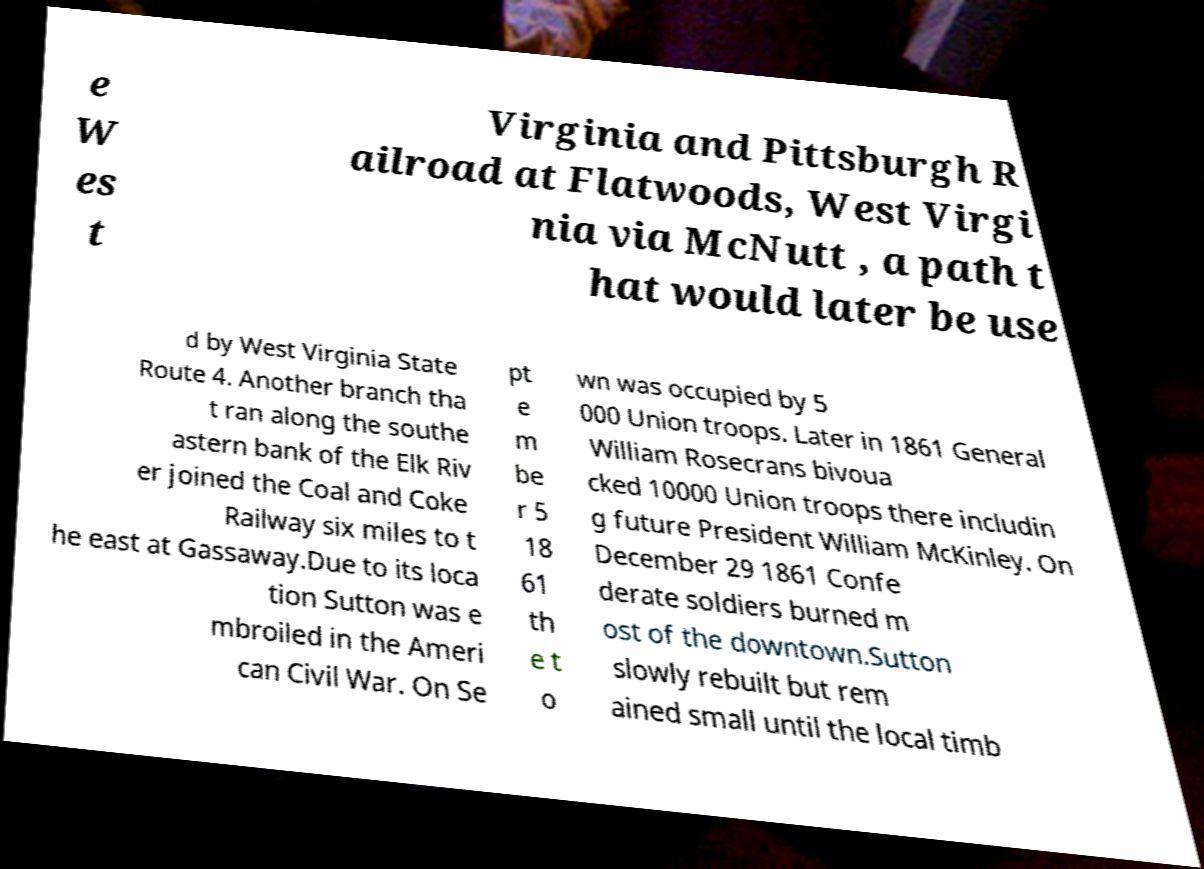Could you assist in decoding the text presented in this image and type it out clearly? e W es t Virginia and Pittsburgh R ailroad at Flatwoods, West Virgi nia via McNutt , a path t hat would later be use d by West Virginia State Route 4. Another branch tha t ran along the southe astern bank of the Elk Riv er joined the Coal and Coke Railway six miles to t he east at Gassaway.Due to its loca tion Sutton was e mbroiled in the Ameri can Civil War. On Se pt e m be r 5 18 61 th e t o wn was occupied by 5 000 Union troops. Later in 1861 General William Rosecrans bivoua cked 10000 Union troops there includin g future President William McKinley. On December 29 1861 Confe derate soldiers burned m ost of the downtown.Sutton slowly rebuilt but rem ained small until the local timb 